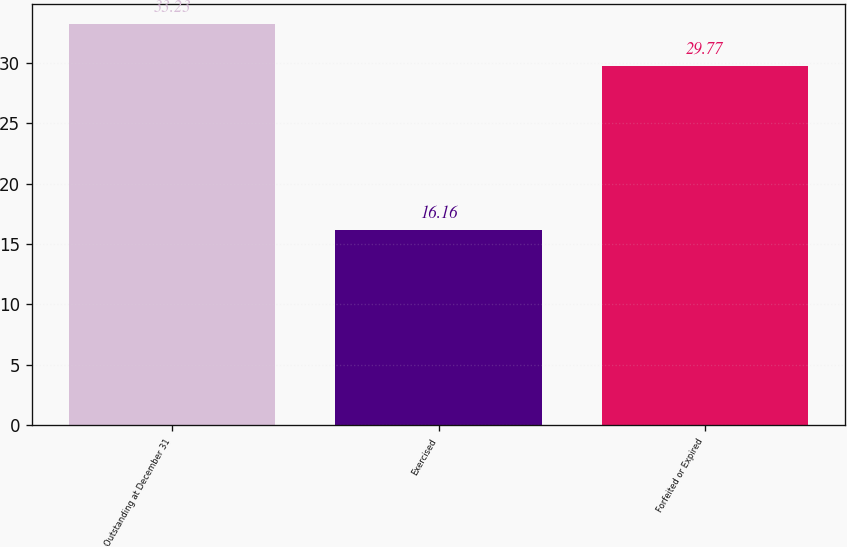Convert chart to OTSL. <chart><loc_0><loc_0><loc_500><loc_500><bar_chart><fcel>Outstanding at December 31<fcel>Exercised<fcel>Forfeited or Expired<nl><fcel>33.23<fcel>16.16<fcel>29.77<nl></chart> 